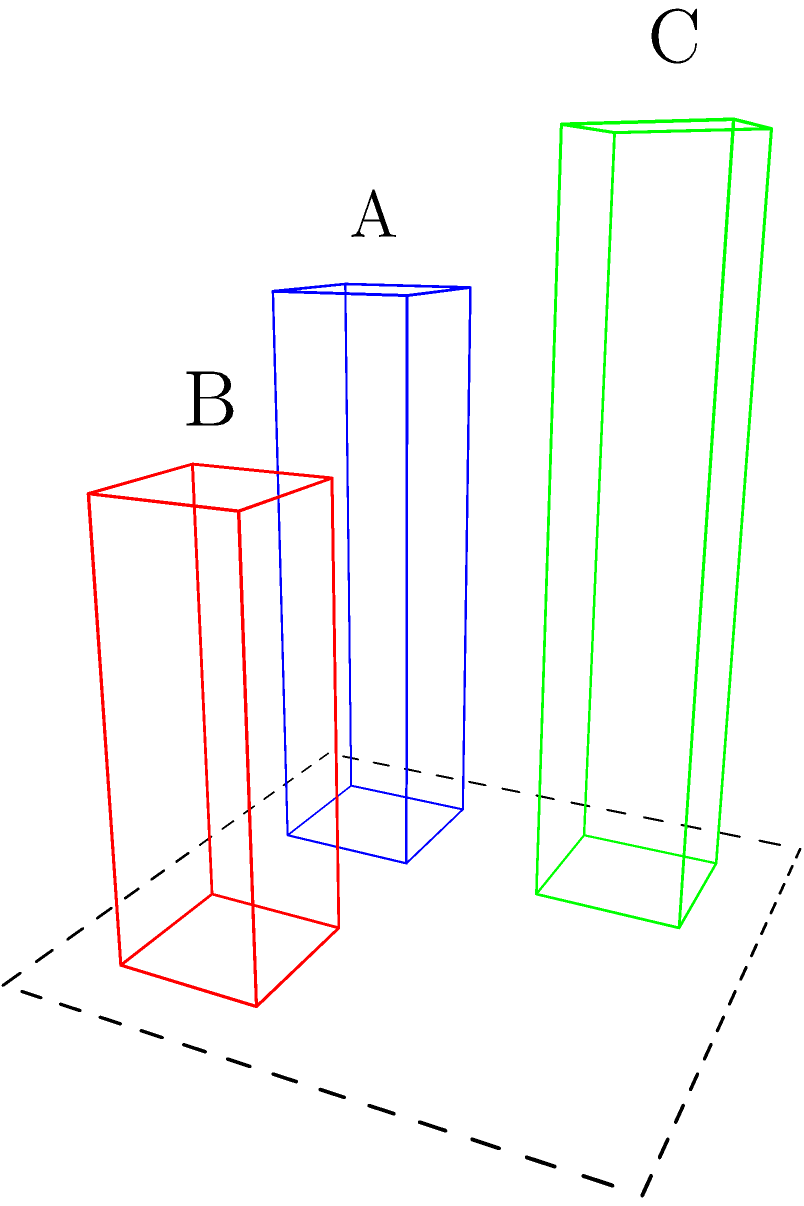In the diagram above, three skyscrapers (A, B, and C) are positioned on a city block. If we rotate the entire configuration 90 degrees clockwise around the z-axis (vertical axis), which skyscraper will be closest to the bottom-right corner of the block? To solve this problem, we need to visualize the rotation of the skyscrapers around the vertical axis. Let's approach this step-by-step:

1. Current positions:
   - Skyscraper A: bottom-left corner
   - Skyscraper B: bottom-right corner
   - Skyscraper C: top-left corner

2. After 90-degree clockwise rotation:
   - Skyscraper A will move to the top-left corner
   - Skyscraper B will move to the bottom-left corner
   - Skyscraper C will move to the bottom-right corner

3. The bottom-right corner after rotation will be where the top-left corner is currently located.

4. Among the three skyscrapers, C is currently in the top-left corner.

Therefore, after the 90-degree clockwise rotation, skyscraper C will be positioned closest to the bottom-right corner of the block.

This problem tests spatial intelligence by requiring the ability to mentally rotate 3D objects and understand their new positions in space, which is crucial for efficient office space planning in skyscrapers.
Answer: C 